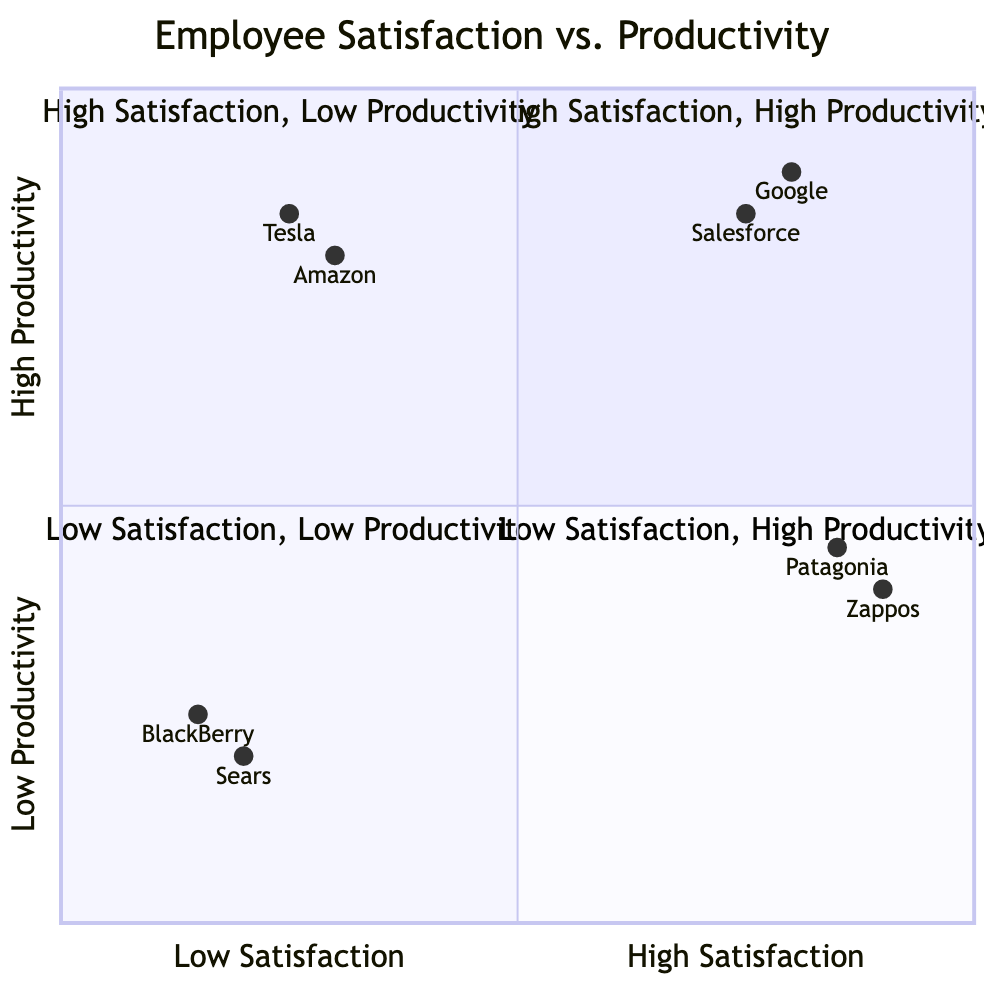What companies fall into the "High Satisfaction, High Productivity" quadrant? The "High Satisfaction, High Productivity" quadrant includes Google and Salesforce, as indicated in the diagram.
Answer: Google, Salesforce Which quadrant contains the company with the lowest satisfaction? The company with the lowest satisfaction is BlackBerry, which is located in the "Low Satisfaction, Low Productivity" quadrant.
Answer: Low Satisfaction, Low Productivity How many companies are identified in the "Low Satisfaction, High Productivity" quadrant? The "Low Satisfaction, High Productivity" quadrant includes two companies: Amazon and Tesla. Counting these companies gives a total of two.
Answer: 2 What is the characteristic associated with companies in the "High Satisfaction, Low Productivity" quadrant? Companies in the "High Satisfaction, Low Productivity" quadrant emphasize supportive management as a characteristic.
Answer: Supportive management What outcome is commonly faced by companies in the "Low Satisfaction, Low Productivity" quadrant? Companies in this quadrant commonly experience declining business performance, as identified in the outcomes.
Answer: Declining business performance Which quadrant has the highest employee morale? The "High Satisfaction, Low Productivity" quadrant is associated with high employee morale due to its supportive and flexible environment.
Answer: High Satisfaction, Low Productivity What is the productivity level of Salesforce? Salesforce has a productivity level represented by a high value in the quadrant chart, specifically at 0.85, indicating high productivity.
Answer: 0.85 Compare the examples of companies in "Low Satisfaction, High Productivity." How many examples are given? The "Low Satisfaction, High Productivity" quadrant includes two examples of companies: Amazon and Tesla. Thus, there are two examples provided.
Answer: 2 Which company demonstrates the least productivity from those listed in the chart? BlackBerry shows the least productivity with a low value of 0.25 in the quadrant chart.
Answer: 0.25 